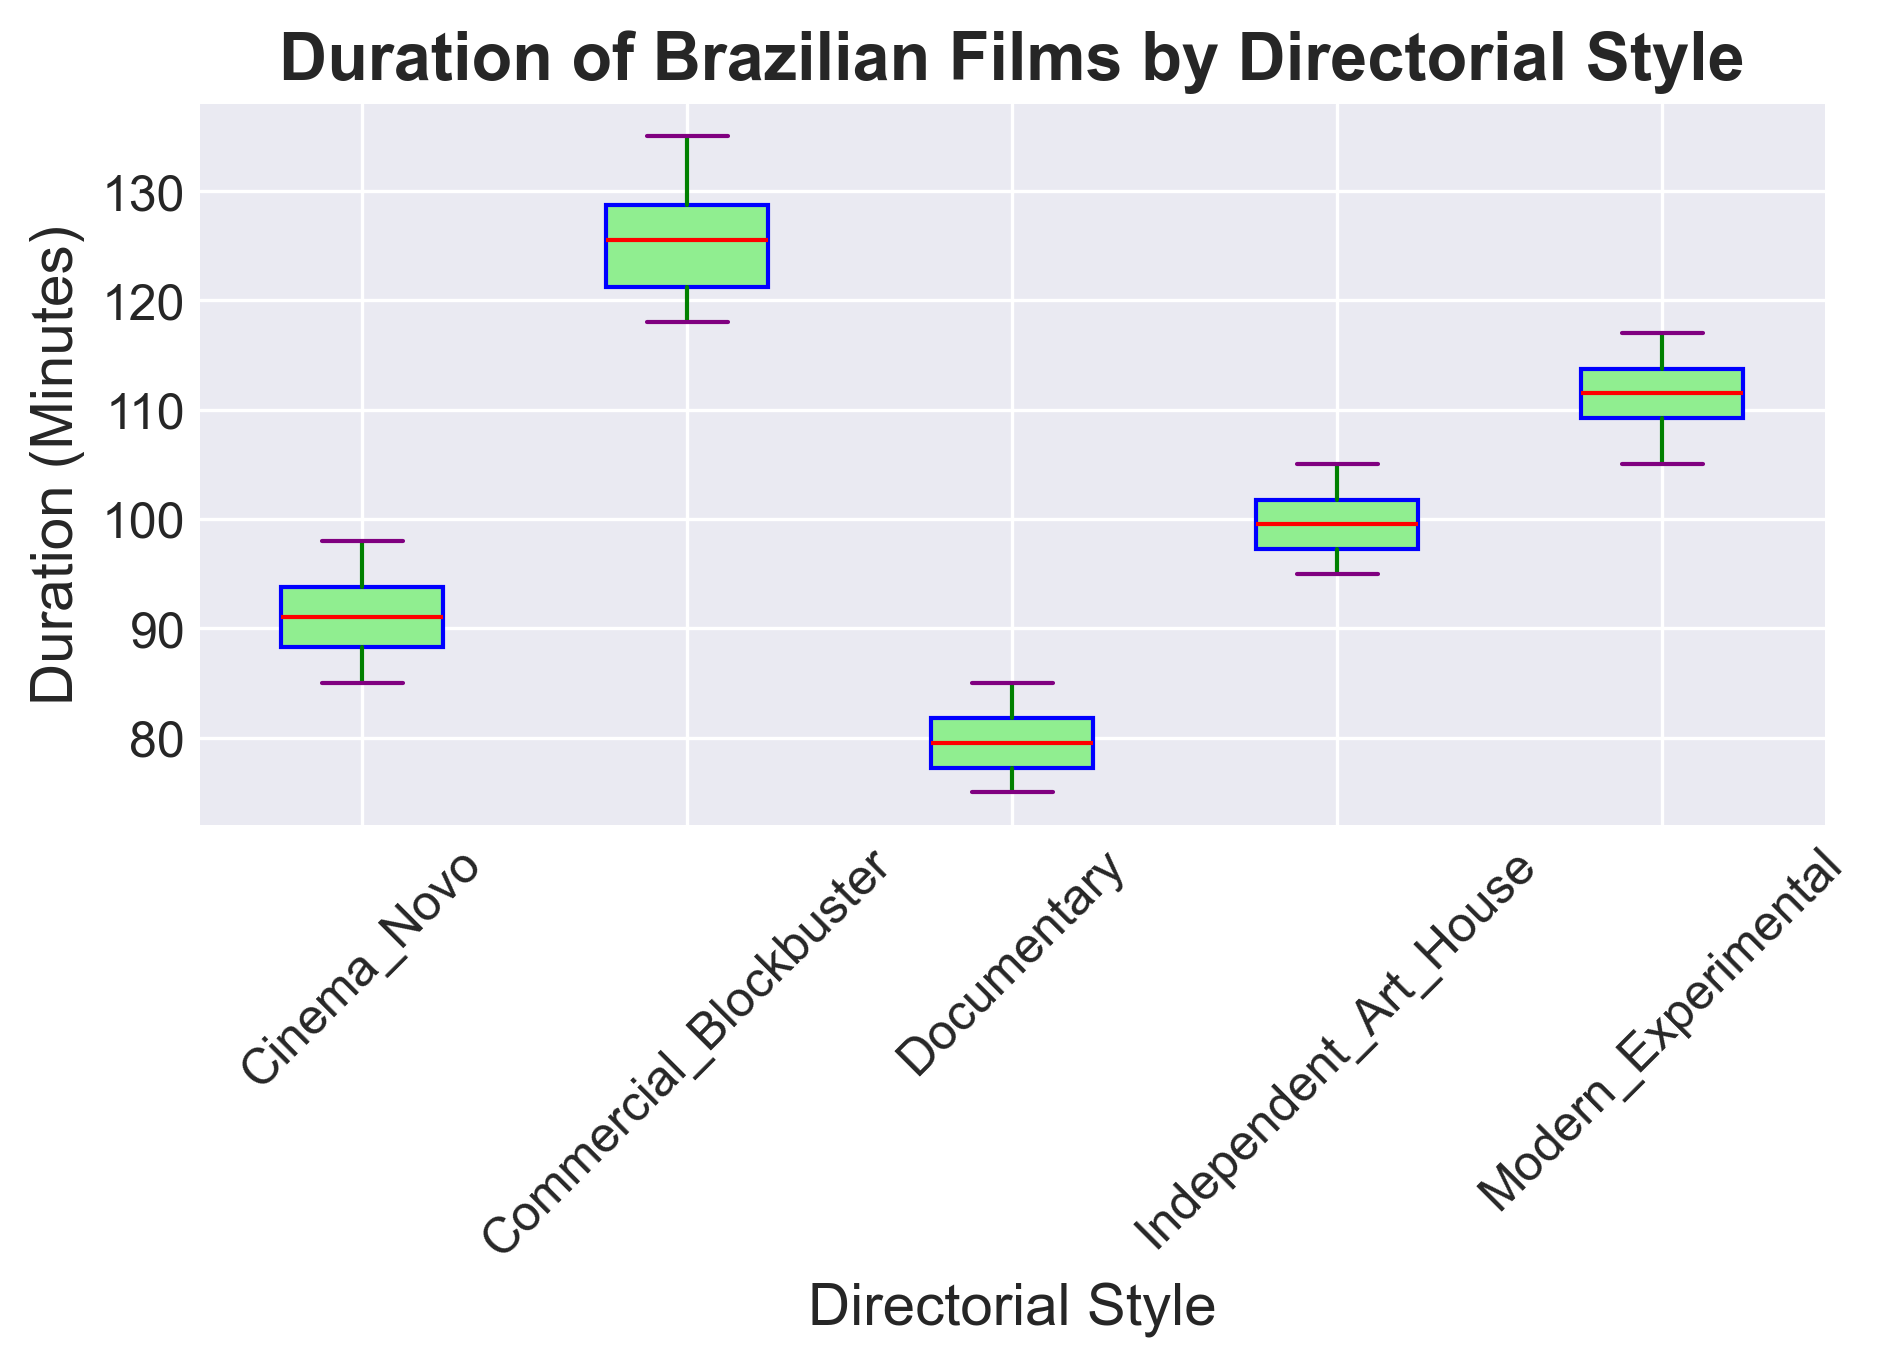What is the median duration of Cinema Novo films? Look at the box plot for Cinema Novo and identify the red line within the box, which represents the median duration.
Answer: 90 minutes Which directorial style has the longest median duration? Compare the positions of the red lines (median) within the boxes for each directorial style. The one with the highest position indicates the longest median duration.
Answer: Commercial Blockbuster Which directorial style exhibits the greatest range in film durations? Identify the directorial style with the widest box and whiskers, which represents the full range from the shortest to the longest film duration.
Answer: Commercial Blockbuster Are the durations of Modern Experimental films generally longer than those of Cinema Novo films? Compare the locations of the boxes and median lines for Modern Experimental and Cinema Novo. Modern Experimental should have a higher median and generally larger values.
Answer: Yes What is the interquartile range (IQR) of Independent Art House films? Identify the heights of the box for Independent Art House, which represents the IQR. Subtract the value at the bottom of the box (25th percentile) from the top of the box (75th percentile).
Answer: 7 minutes Which directorial style has the shortest maximum film duration? Look at the maximum values indicated by the top whisker for each directorial style and identify the one with the lowest position.
Answer: Documentary Which film genres show overlap in their duration ranges? Identify boxes and whiskers for different genres that overlap vertically.
Answer: Cinema Novo and Independent Art House, Cinema Novo and Documentary, Modern Experimental and Commercial Blockbuster Which genre has the most outliers? Look for the red dots outside the whiskers (whiskers represent the range of durations without outliers) and count the outliers for each genre.
Answer: None (all data points fit within the whiskers) Which genres have similar medians? Compare the positions of the red median lines and identify those genres that are close together.
Answer: Cinema Novo and Independent Art House How do the ranges of durations for Cinema Novo and Documentary compare visually? Compare the visual lengths of the whiskers and boxes for Cinema Novo and Documentary.
Answer: Cinema Novo has a longer range 